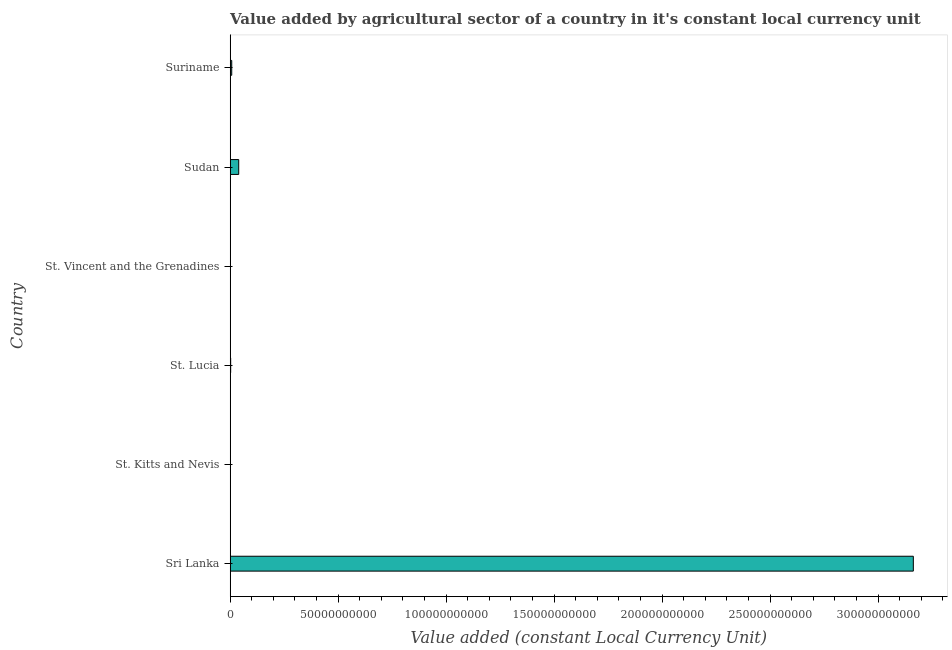Does the graph contain grids?
Offer a terse response. No. What is the title of the graph?
Your answer should be compact. Value added by agricultural sector of a country in it's constant local currency unit. What is the label or title of the X-axis?
Offer a very short reply. Value added (constant Local Currency Unit). What is the value added by agriculture sector in St. Vincent and the Grenadines?
Make the answer very short. 1.02e+08. Across all countries, what is the maximum value added by agriculture sector?
Ensure brevity in your answer.  3.16e+11. Across all countries, what is the minimum value added by agriculture sector?
Offer a terse response. 2.21e+07. In which country was the value added by agriculture sector maximum?
Your answer should be compact. Sri Lanka. In which country was the value added by agriculture sector minimum?
Ensure brevity in your answer.  St. Kitts and Nevis. What is the sum of the value added by agriculture sector?
Give a very brief answer. 3.21e+11. What is the difference between the value added by agriculture sector in Sri Lanka and St. Lucia?
Keep it short and to the point. 3.16e+11. What is the average value added by agriculture sector per country?
Offer a very short reply. 5.36e+1. What is the median value added by agriculture sector?
Your answer should be compact. 4.74e+08. In how many countries, is the value added by agriculture sector greater than 220000000000 LCU?
Your answer should be compact. 1. What is the ratio of the value added by agriculture sector in Sri Lanka to that in St. Lucia?
Offer a very short reply. 1394.33. Is the value added by agriculture sector in St. Vincent and the Grenadines less than that in Sudan?
Make the answer very short. Yes. What is the difference between the highest and the second highest value added by agriculture sector?
Offer a very short reply. 3.12e+11. Is the sum of the value added by agriculture sector in St. Kitts and Nevis and Suriname greater than the maximum value added by agriculture sector across all countries?
Your response must be concise. No. What is the difference between the highest and the lowest value added by agriculture sector?
Ensure brevity in your answer.  3.16e+11. In how many countries, is the value added by agriculture sector greater than the average value added by agriculture sector taken over all countries?
Your answer should be very brief. 1. How many bars are there?
Keep it short and to the point. 6. Are all the bars in the graph horizontal?
Make the answer very short. Yes. How many countries are there in the graph?
Your response must be concise. 6. Are the values on the major ticks of X-axis written in scientific E-notation?
Your answer should be very brief. No. What is the Value added (constant Local Currency Unit) in Sri Lanka?
Keep it short and to the point. 3.16e+11. What is the Value added (constant Local Currency Unit) of St. Kitts and Nevis?
Keep it short and to the point. 2.21e+07. What is the Value added (constant Local Currency Unit) of St. Lucia?
Keep it short and to the point. 2.27e+08. What is the Value added (constant Local Currency Unit) of St. Vincent and the Grenadines?
Keep it short and to the point. 1.02e+08. What is the Value added (constant Local Currency Unit) of Sudan?
Your answer should be compact. 3.95e+09. What is the Value added (constant Local Currency Unit) of Suriname?
Provide a short and direct response. 7.20e+08. What is the difference between the Value added (constant Local Currency Unit) in Sri Lanka and St. Kitts and Nevis?
Make the answer very short. 3.16e+11. What is the difference between the Value added (constant Local Currency Unit) in Sri Lanka and St. Lucia?
Offer a terse response. 3.16e+11. What is the difference between the Value added (constant Local Currency Unit) in Sri Lanka and St. Vincent and the Grenadines?
Offer a terse response. 3.16e+11. What is the difference between the Value added (constant Local Currency Unit) in Sri Lanka and Sudan?
Your answer should be compact. 3.12e+11. What is the difference between the Value added (constant Local Currency Unit) in Sri Lanka and Suriname?
Your response must be concise. 3.16e+11. What is the difference between the Value added (constant Local Currency Unit) in St. Kitts and Nevis and St. Lucia?
Keep it short and to the point. -2.05e+08. What is the difference between the Value added (constant Local Currency Unit) in St. Kitts and Nevis and St. Vincent and the Grenadines?
Your response must be concise. -7.95e+07. What is the difference between the Value added (constant Local Currency Unit) in St. Kitts and Nevis and Sudan?
Ensure brevity in your answer.  -3.93e+09. What is the difference between the Value added (constant Local Currency Unit) in St. Kitts and Nevis and Suriname?
Offer a terse response. -6.98e+08. What is the difference between the Value added (constant Local Currency Unit) in St. Lucia and St. Vincent and the Grenadines?
Ensure brevity in your answer.  1.25e+08. What is the difference between the Value added (constant Local Currency Unit) in St. Lucia and Sudan?
Give a very brief answer. -3.73e+09. What is the difference between the Value added (constant Local Currency Unit) in St. Lucia and Suriname?
Give a very brief answer. -4.93e+08. What is the difference between the Value added (constant Local Currency Unit) in St. Vincent and the Grenadines and Sudan?
Your answer should be very brief. -3.85e+09. What is the difference between the Value added (constant Local Currency Unit) in St. Vincent and the Grenadines and Suriname?
Ensure brevity in your answer.  -6.19e+08. What is the difference between the Value added (constant Local Currency Unit) in Sudan and Suriname?
Your answer should be compact. 3.23e+09. What is the ratio of the Value added (constant Local Currency Unit) in Sri Lanka to that in St. Kitts and Nevis?
Keep it short and to the point. 1.43e+04. What is the ratio of the Value added (constant Local Currency Unit) in Sri Lanka to that in St. Lucia?
Your answer should be compact. 1394.33. What is the ratio of the Value added (constant Local Currency Unit) in Sri Lanka to that in St. Vincent and the Grenadines?
Ensure brevity in your answer.  3114.24. What is the ratio of the Value added (constant Local Currency Unit) in Sri Lanka to that in Sudan?
Provide a short and direct response. 80.03. What is the ratio of the Value added (constant Local Currency Unit) in Sri Lanka to that in Suriname?
Your answer should be very brief. 439.25. What is the ratio of the Value added (constant Local Currency Unit) in St. Kitts and Nevis to that in St. Lucia?
Make the answer very short. 0.1. What is the ratio of the Value added (constant Local Currency Unit) in St. Kitts and Nevis to that in St. Vincent and the Grenadines?
Your answer should be compact. 0.22. What is the ratio of the Value added (constant Local Currency Unit) in St. Kitts and Nevis to that in Sudan?
Make the answer very short. 0.01. What is the ratio of the Value added (constant Local Currency Unit) in St. Kitts and Nevis to that in Suriname?
Your answer should be compact. 0.03. What is the ratio of the Value added (constant Local Currency Unit) in St. Lucia to that in St. Vincent and the Grenadines?
Make the answer very short. 2.23. What is the ratio of the Value added (constant Local Currency Unit) in St. Lucia to that in Sudan?
Make the answer very short. 0.06. What is the ratio of the Value added (constant Local Currency Unit) in St. Lucia to that in Suriname?
Offer a terse response. 0.32. What is the ratio of the Value added (constant Local Currency Unit) in St. Vincent and the Grenadines to that in Sudan?
Ensure brevity in your answer.  0.03. What is the ratio of the Value added (constant Local Currency Unit) in St. Vincent and the Grenadines to that in Suriname?
Your answer should be compact. 0.14. What is the ratio of the Value added (constant Local Currency Unit) in Sudan to that in Suriname?
Keep it short and to the point. 5.49. 